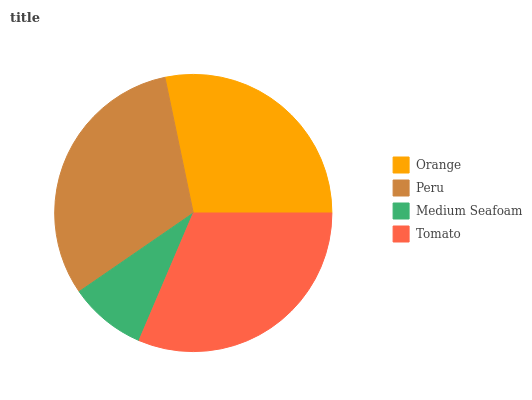Is Medium Seafoam the minimum?
Answer yes or no. Yes. Is Tomato the maximum?
Answer yes or no. Yes. Is Peru the minimum?
Answer yes or no. No. Is Peru the maximum?
Answer yes or no. No. Is Peru greater than Orange?
Answer yes or no. Yes. Is Orange less than Peru?
Answer yes or no. Yes. Is Orange greater than Peru?
Answer yes or no. No. Is Peru less than Orange?
Answer yes or no. No. Is Peru the high median?
Answer yes or no. Yes. Is Orange the low median?
Answer yes or no. Yes. Is Medium Seafoam the high median?
Answer yes or no. No. Is Medium Seafoam the low median?
Answer yes or no. No. 